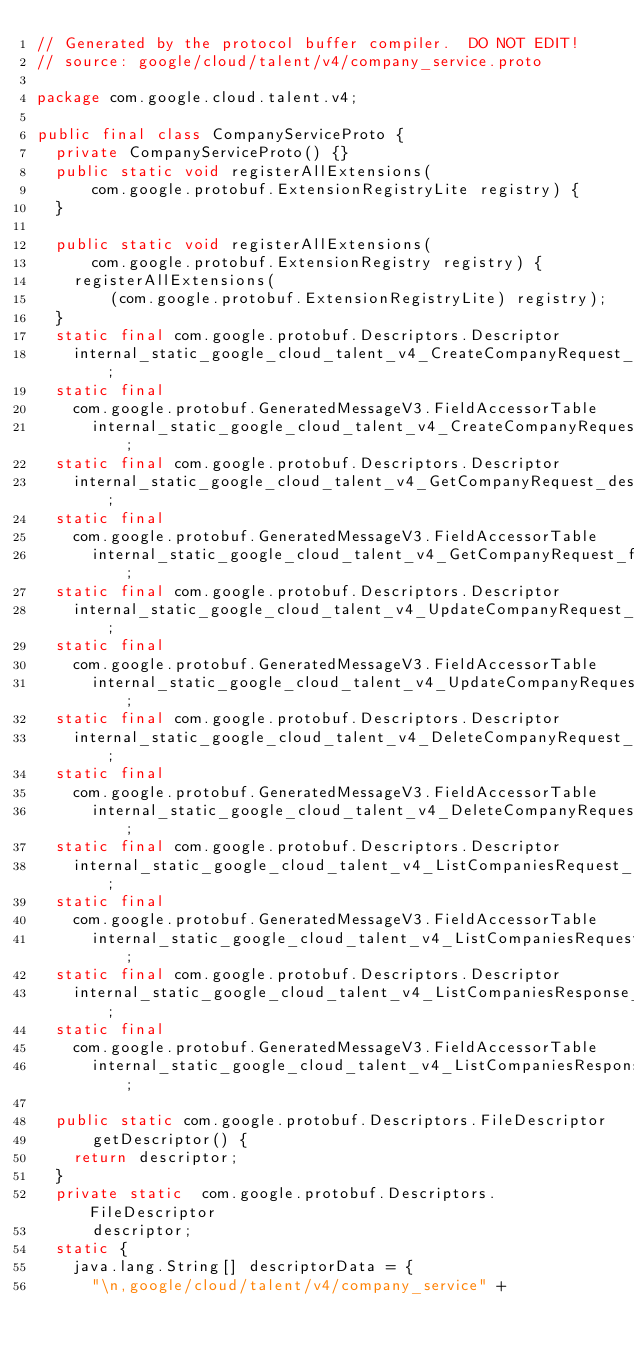Convert code to text. <code><loc_0><loc_0><loc_500><loc_500><_Java_>// Generated by the protocol buffer compiler.  DO NOT EDIT!
// source: google/cloud/talent/v4/company_service.proto

package com.google.cloud.talent.v4;

public final class CompanyServiceProto {
  private CompanyServiceProto() {}
  public static void registerAllExtensions(
      com.google.protobuf.ExtensionRegistryLite registry) {
  }

  public static void registerAllExtensions(
      com.google.protobuf.ExtensionRegistry registry) {
    registerAllExtensions(
        (com.google.protobuf.ExtensionRegistryLite) registry);
  }
  static final com.google.protobuf.Descriptors.Descriptor
    internal_static_google_cloud_talent_v4_CreateCompanyRequest_descriptor;
  static final 
    com.google.protobuf.GeneratedMessageV3.FieldAccessorTable
      internal_static_google_cloud_talent_v4_CreateCompanyRequest_fieldAccessorTable;
  static final com.google.protobuf.Descriptors.Descriptor
    internal_static_google_cloud_talent_v4_GetCompanyRequest_descriptor;
  static final 
    com.google.protobuf.GeneratedMessageV3.FieldAccessorTable
      internal_static_google_cloud_talent_v4_GetCompanyRequest_fieldAccessorTable;
  static final com.google.protobuf.Descriptors.Descriptor
    internal_static_google_cloud_talent_v4_UpdateCompanyRequest_descriptor;
  static final 
    com.google.protobuf.GeneratedMessageV3.FieldAccessorTable
      internal_static_google_cloud_talent_v4_UpdateCompanyRequest_fieldAccessorTable;
  static final com.google.protobuf.Descriptors.Descriptor
    internal_static_google_cloud_talent_v4_DeleteCompanyRequest_descriptor;
  static final 
    com.google.protobuf.GeneratedMessageV3.FieldAccessorTable
      internal_static_google_cloud_talent_v4_DeleteCompanyRequest_fieldAccessorTable;
  static final com.google.protobuf.Descriptors.Descriptor
    internal_static_google_cloud_talent_v4_ListCompaniesRequest_descriptor;
  static final 
    com.google.protobuf.GeneratedMessageV3.FieldAccessorTable
      internal_static_google_cloud_talent_v4_ListCompaniesRequest_fieldAccessorTable;
  static final com.google.protobuf.Descriptors.Descriptor
    internal_static_google_cloud_talent_v4_ListCompaniesResponse_descriptor;
  static final 
    com.google.protobuf.GeneratedMessageV3.FieldAccessorTable
      internal_static_google_cloud_talent_v4_ListCompaniesResponse_fieldAccessorTable;

  public static com.google.protobuf.Descriptors.FileDescriptor
      getDescriptor() {
    return descriptor;
  }
  private static  com.google.protobuf.Descriptors.FileDescriptor
      descriptor;
  static {
    java.lang.String[] descriptorData = {
      "\n,google/cloud/talent/v4/company_service" +</code> 